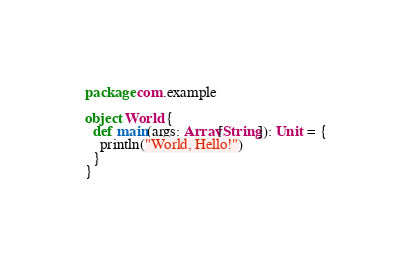<code> <loc_0><loc_0><loc_500><loc_500><_Scala_>package com.example

object World {
  def main(args: Array[String]): Unit = {
    println("World, Hello!")
  }
}

</code> 